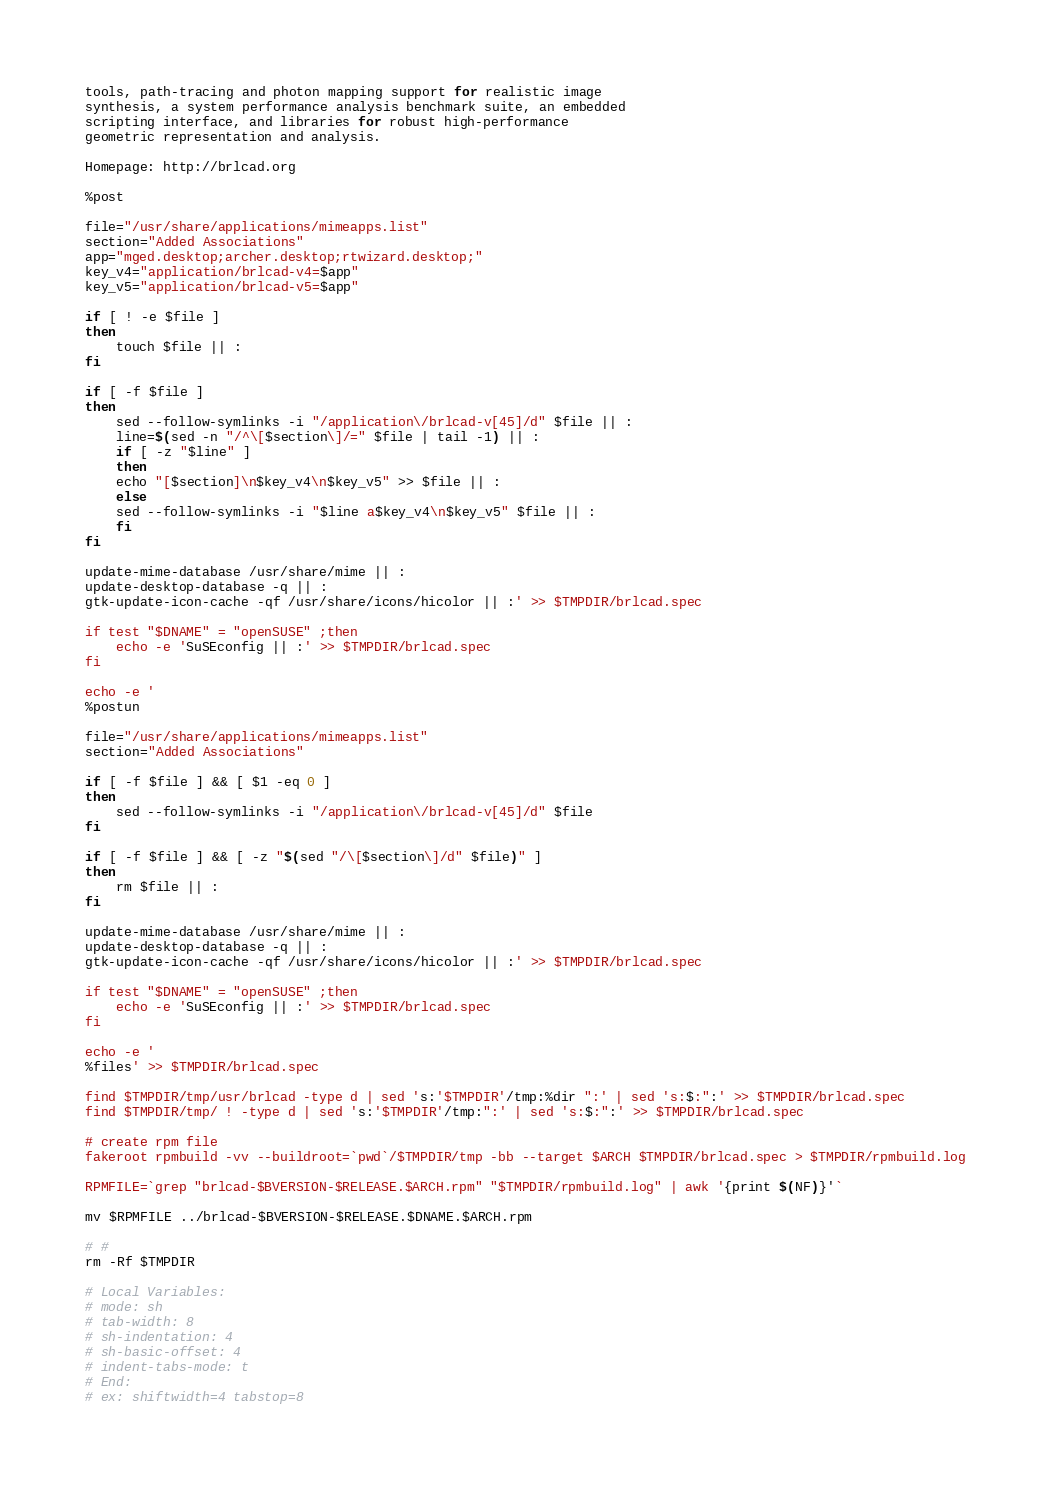<code> <loc_0><loc_0><loc_500><loc_500><_Bash_>tools, path-tracing and photon mapping support for realistic image
synthesis, a system performance analysis benchmark suite, an embedded
scripting interface, and libraries for robust high-performance
geometric representation and analysis.

Homepage: http://brlcad.org

%post

file="/usr/share/applications/mimeapps.list"
section="Added Associations"
app="mged.desktop;archer.desktop;rtwizard.desktop;"
key_v4="application/brlcad-v4=$app"
key_v5="application/brlcad-v5=$app"

if [ ! -e $file ]
then
    touch $file || :
fi

if [ -f $file ]
then
    sed --follow-symlinks -i "/application\/brlcad-v[45]/d" $file || :
    line=$(sed -n "/^\[$section\]/=" $file | tail -1) || :
    if [ -z "$line" ]
    then
	echo "[$section]\n$key_v4\n$key_v5" >> $file || :
    else
	sed --follow-symlinks -i "$line a$key_v4\n$key_v5" $file || :
    fi
fi

update-mime-database /usr/share/mime || :
update-desktop-database -q || :
gtk-update-icon-cache -qf /usr/share/icons/hicolor || :' >> $TMPDIR/brlcad.spec

if test "$DNAME" = "openSUSE" ;then
    echo -e 'SuSEconfig || :' >> $TMPDIR/brlcad.spec
fi

echo -e '
%postun

file="/usr/share/applications/mimeapps.list"
section="Added Associations"

if [ -f $file ] && [ $1 -eq 0 ]
then
    sed --follow-symlinks -i "/application\/brlcad-v[45]/d" $file
fi

if [ -f $file ] && [ -z "$(sed "/\[$section\]/d" $file)" ]
then
    rm $file || :
fi

update-mime-database /usr/share/mime || :
update-desktop-database -q || :
gtk-update-icon-cache -qf /usr/share/icons/hicolor || :' >> $TMPDIR/brlcad.spec

if test "$DNAME" = "openSUSE" ;then
    echo -e 'SuSEconfig || :' >> $TMPDIR/brlcad.spec
fi

echo -e '
%files' >> $TMPDIR/brlcad.spec

find $TMPDIR/tmp/usr/brlcad -type d | sed 's:'$TMPDIR'/tmp:%dir ":' | sed 's:$:":' >> $TMPDIR/brlcad.spec
find $TMPDIR/tmp/ ! -type d | sed 's:'$TMPDIR'/tmp:":' | sed 's:$:":' >> $TMPDIR/brlcad.spec

# create rpm file
fakeroot rpmbuild -vv --buildroot=`pwd`/$TMPDIR/tmp -bb --target $ARCH $TMPDIR/brlcad.spec > $TMPDIR/rpmbuild.log

RPMFILE=`grep "brlcad-$BVERSION-$RELEASE.$ARCH.rpm" "$TMPDIR/rpmbuild.log" | awk '{print $(NF)}'`

mv $RPMFILE ../brlcad-$BVERSION-$RELEASE.$DNAME.$ARCH.rpm

# #
rm -Rf $TMPDIR

# Local Variables:
# mode: sh
# tab-width: 8
# sh-indentation: 4
# sh-basic-offset: 4
# indent-tabs-mode: t
# End:
# ex: shiftwidth=4 tabstop=8
</code> 